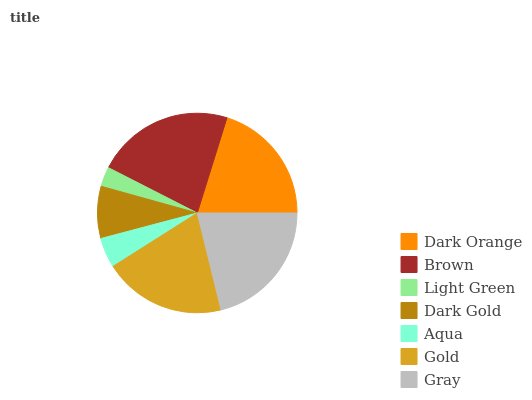Is Light Green the minimum?
Answer yes or no. Yes. Is Brown the maximum?
Answer yes or no. Yes. Is Brown the minimum?
Answer yes or no. No. Is Light Green the maximum?
Answer yes or no. No. Is Brown greater than Light Green?
Answer yes or no. Yes. Is Light Green less than Brown?
Answer yes or no. Yes. Is Light Green greater than Brown?
Answer yes or no. No. Is Brown less than Light Green?
Answer yes or no. No. Is Gold the high median?
Answer yes or no. Yes. Is Gold the low median?
Answer yes or no. Yes. Is Dark Gold the high median?
Answer yes or no. No. Is Light Green the low median?
Answer yes or no. No. 